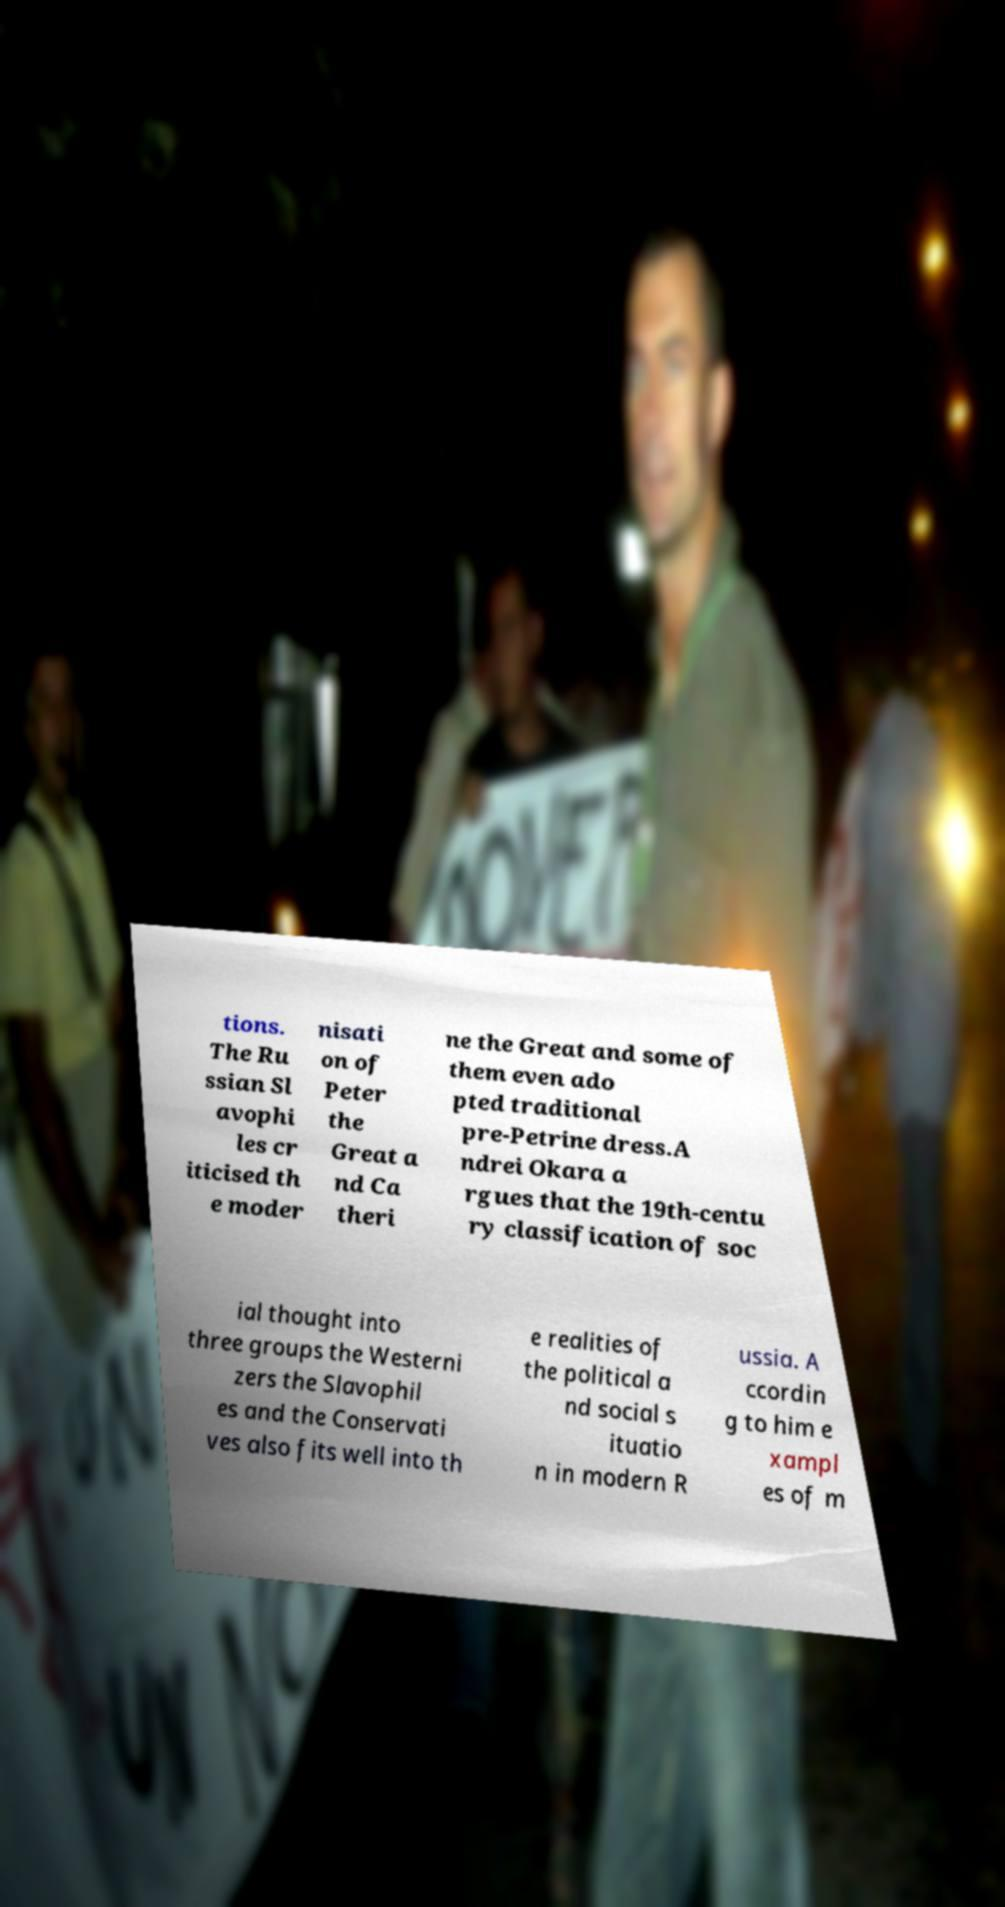I need the written content from this picture converted into text. Can you do that? tions. The Ru ssian Sl avophi les cr iticised th e moder nisati on of Peter the Great a nd Ca theri ne the Great and some of them even ado pted traditional pre-Petrine dress.A ndrei Okara a rgues that the 19th-centu ry classification of soc ial thought into three groups the Westerni zers the Slavophil es and the Conservati ves also fits well into th e realities of the political a nd social s ituatio n in modern R ussia. A ccordin g to him e xampl es of m 